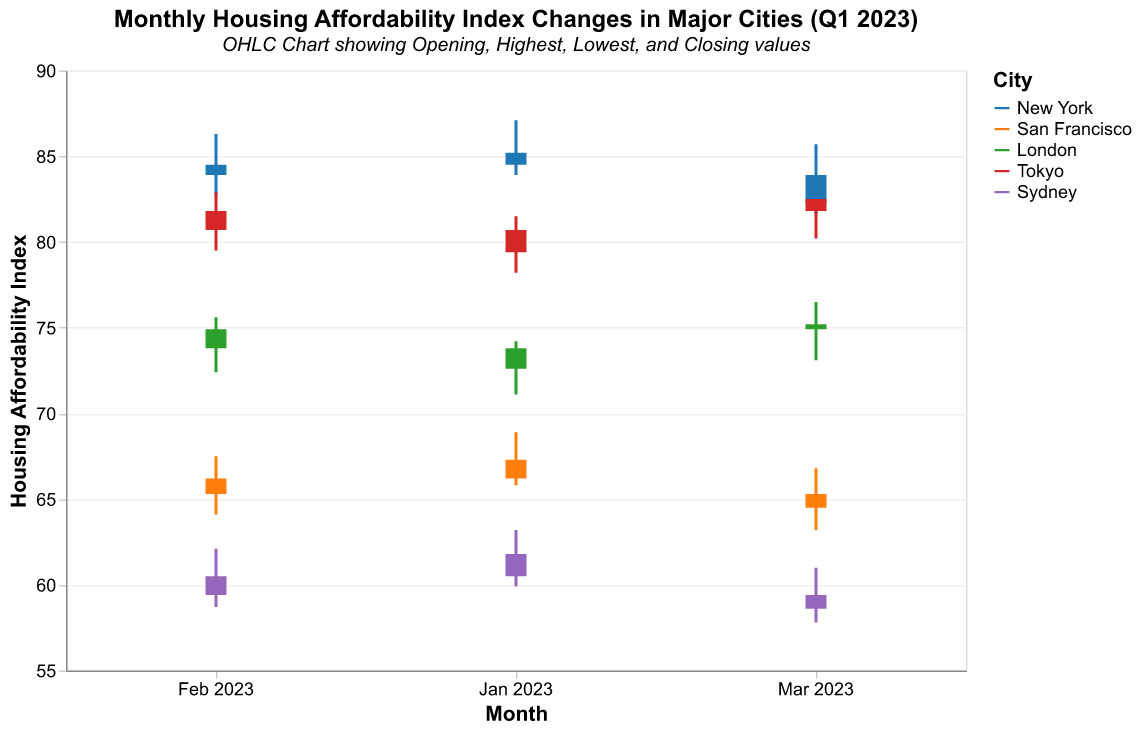What is the title of the figure? The title is located at the top of the figure. It provides a summary of what the chart represents.
Answer: Monthly Housing Affordability Index Changes in Major Cities (Q1 2023) Which city has the lowest closing value in January 2023? Check the closing values for each city in January 2023. The city with the smallest value is the one with the lowest closing value.
Answer: Sydney What is the average housing affordability index for New York over the three months? Sum up the monthly closing values for New York (84.5, 83.9, 82.3) and divide by the number of months (3).
Answer: 83.6 Which city shows the most significant drop in the affordability index from January to March 2023? Calculate the difference between the opening and closing values in January and March for each city and choose the city with the highest negative change.
Answer: Sydney Compare the highest values recorded in January 2023 for all the cities. Which city had the highest peak? Look at the highest values for each city in January and note which one is the greatest.
Answer: Tokyo By how much did San Francisco’s housing affordability index decrease from January 2023 to March 2023? Subtract San Francisco's closing value in March (64.5) from January's closing value (66.2) and determine the difference.
Answer: 1.7 Which city had the smallest range between the highest and lowest values in February 2023? For each city in February, subtract the lowest value from the highest value. The city with the smallest difference has the smallest range.
Answer: Sydney In March 2023, did the closing value for London increase or decrease compared to February 2023? Compare the closing values for London in February (74.9) and March (75.2). Determine whether it increased or decreased.
Answer: Increase What is the average closing value for Sydney over the three months? Sum up the closing values for Sydney (60.5, 59.4, 58.6) and divide by the number of months (3).
Answer: 59.5 